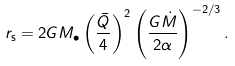Convert formula to latex. <formula><loc_0><loc_0><loc_500><loc_500>r _ { \mathrm s } = 2 G M _ { \bullet } \left ( \frac { \bar { Q } } { 4 } \right ) ^ { 2 } \left ( \frac { G \dot { M } } { 2 \alpha } \right ) ^ { - 2 / 3 } .</formula> 